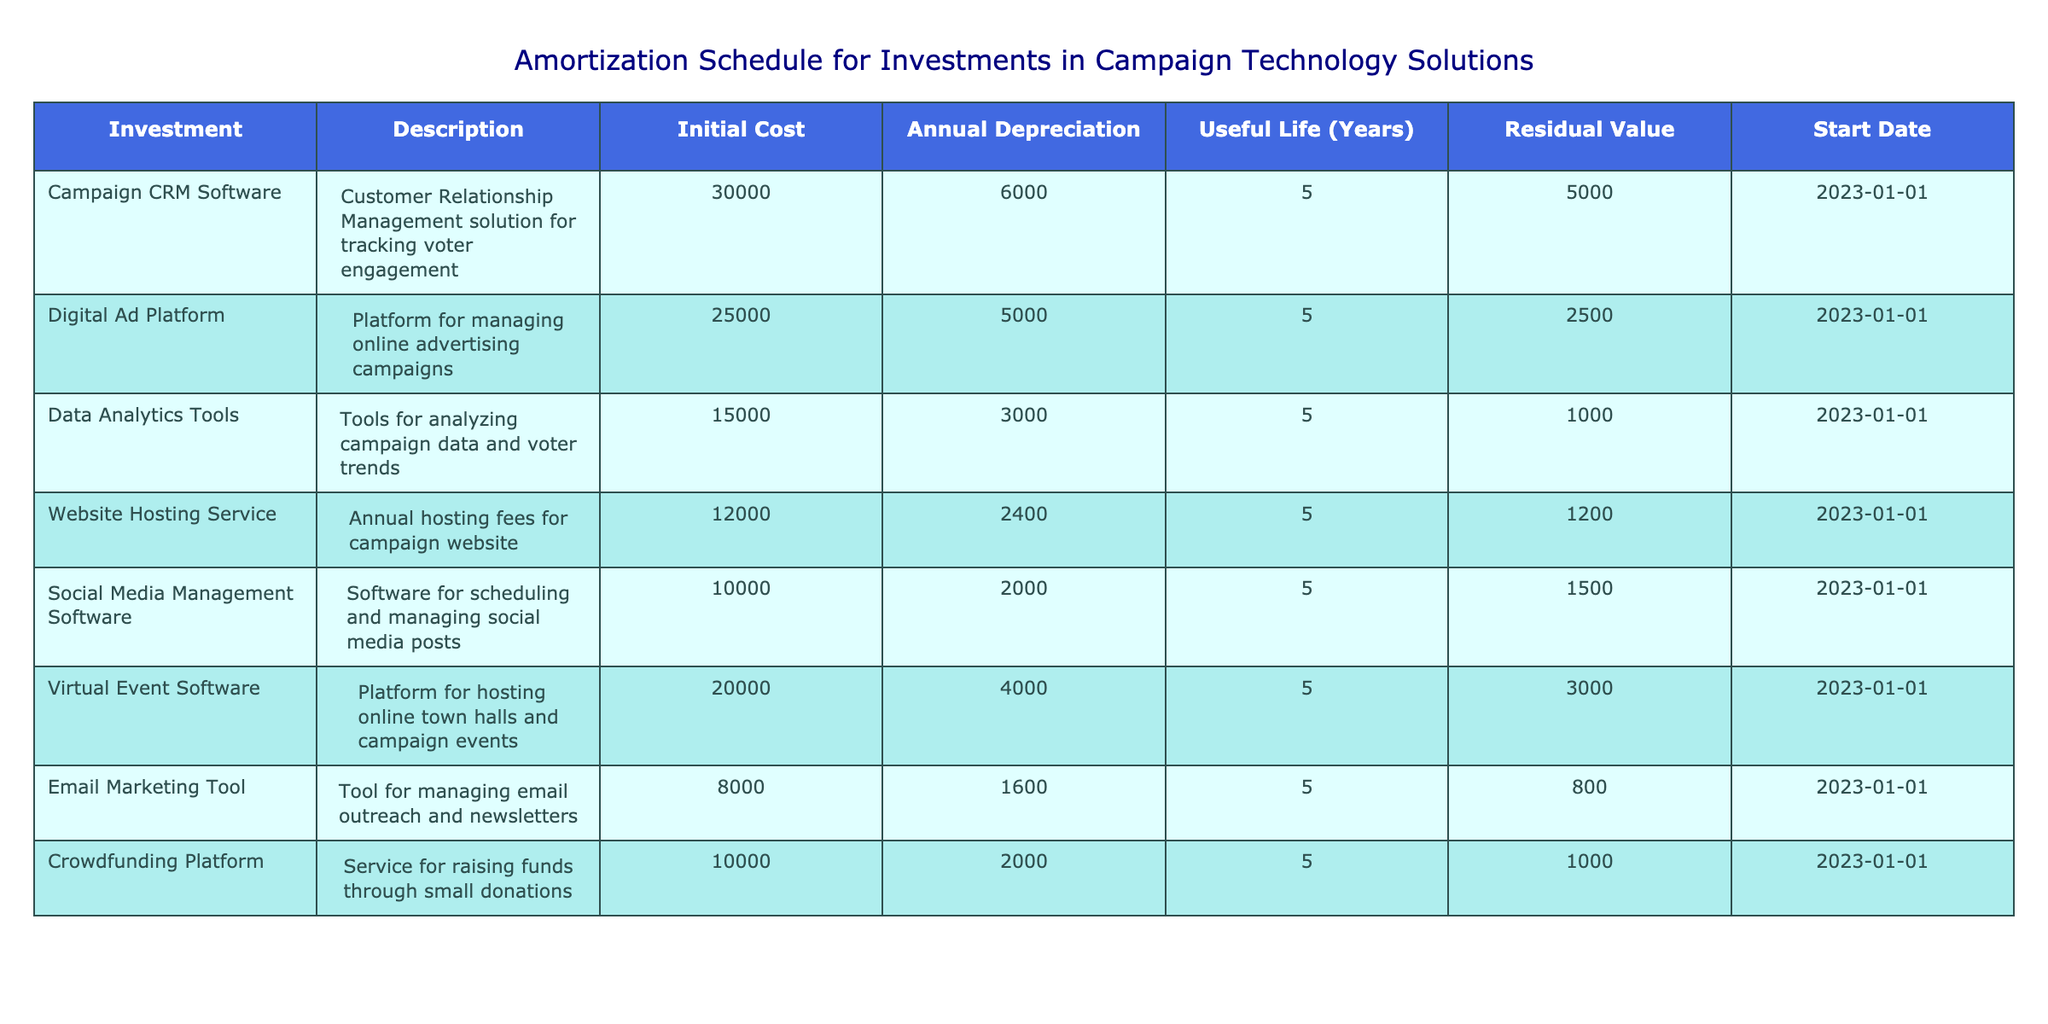What is the initial cost of the “Digital Ad Platform”? According to the table, the initial cost for the Digital Ad Platform is listed directly under the Initial Cost column. Thus, we can find that value easily without any calculations.
Answer: 25000 What is the annual depreciation for the “Campaign CRM Software”? The annual depreciation for the Campaign CRM Software is provided directly in the table under the Annual Depreciation column without needing to calculate.
Answer: 6000 Which technology solution has the lowest residual value? By reviewing the Residual Value column in the table, we find that the Email Marketing Tool has a residual value of 800, which is the lowest compared to other solutions listed.
Answer: Email Marketing Tool What is the total initial cost of all campaign technology solutions? To get the total initial cost, sum up all the initial costs from each row: 30000 + 25000 + 15000 + 12000 + 10000 + 20000 + 8000 + 10000 = 130000. Thus the total initial cost of all campaign technology solutions is obtained.
Answer: 130000 Is the useful life of the “Social Media Management Software” the same as the “Email Marketing Tool”? Both the Social Media Management Software and the Email Marketing Tool have a useful life of 5 years as indicated in the Useful Life column. Therefore, the answer to this question is yes.
Answer: Yes What is the average annual depreciation across all technology solutions? To find the average annual depreciation, sum all the annual depreciations: 6000 + 5000 + 3000 + 2400 + 2000 + 4000 + 1600 + 2000 = 21000. Then divide this sum by the number of solutions, which is 8: 21000 / 8 = 2625. This gives us the average annual depreciation of the technology solutions.
Answer: 2625 Which solutions have an annual depreciation greater than 4000? Looking at the Annual Depreciation column, we see that the Campaign CRM Software (6000) and the Virtual Event Software (4000) have annual depreciations greater than 4000. Thus, there are two solutions meeting the criteria.
Answer: Campaign CRM Software, Virtual Event Software What is the difference between the initial cost of the "Crowdfunding Platform" and the "Data Analytics Tools"? The initial cost of the Crowdfunding Platform is 10000, and for the Data Analytics Tools, it is 15000. To find the difference, subtract the initial cost of the Crowdfunding Platform from that of the Data Analytics Tools: 15000 - 10000 = 5000.
Answer: 5000 Which technology solution has an initial cost that is more than the average initial cost? The average initial cost can be calculated first by summing all initial costs (130000) and dividing by the number of solutions (8), which gives us 16250. Then, we see that the Campaign CRM Software, Digital Ad Platform, and the Virtual Event Software have initial costs greater than 16250.
Answer: Campaign CRM Software, Digital Ad Platform, Virtual Event Software 